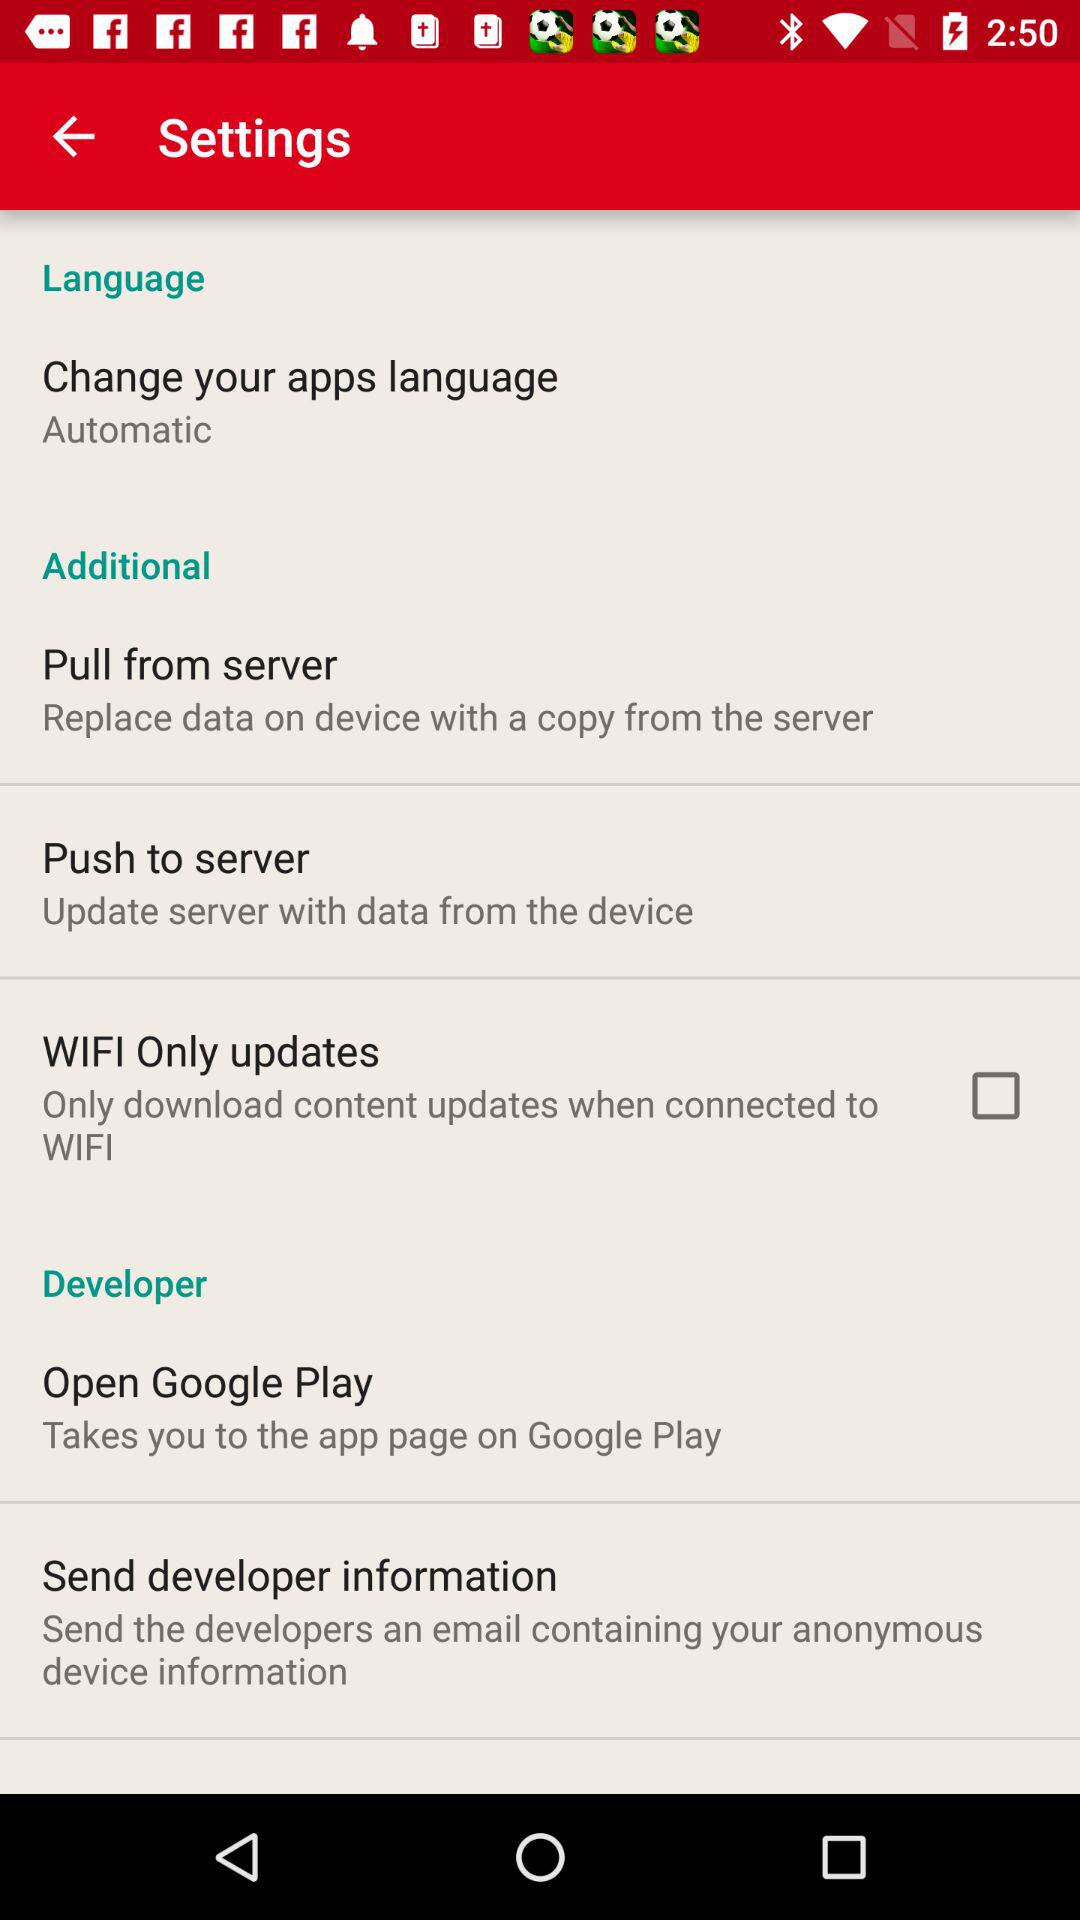How can we replace the data on the device with a copy from the server? You can replace the data on the device with a copy from the server through the option "Pull from server". 